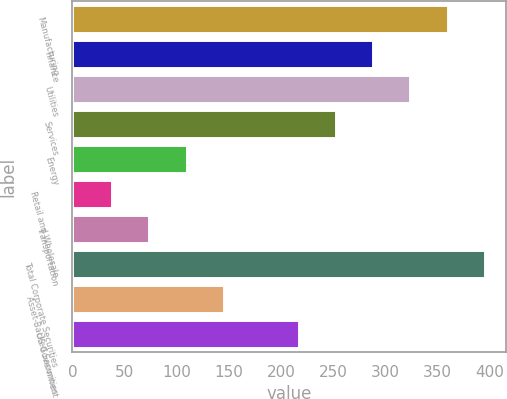Convert chart. <chart><loc_0><loc_0><loc_500><loc_500><bar_chart><fcel>Manufacturing<fcel>Finance<fcel>Utilities<fcel>Services<fcel>Energy<fcel>Retail and Wholesale<fcel>Transportation<fcel>Total Corporate Securities<fcel>Asset-Backed Securities<fcel>US Government<nl><fcel>360<fcel>288.4<fcel>324.2<fcel>252.6<fcel>109.4<fcel>37.8<fcel>73.6<fcel>395.8<fcel>145.2<fcel>216.8<nl></chart> 